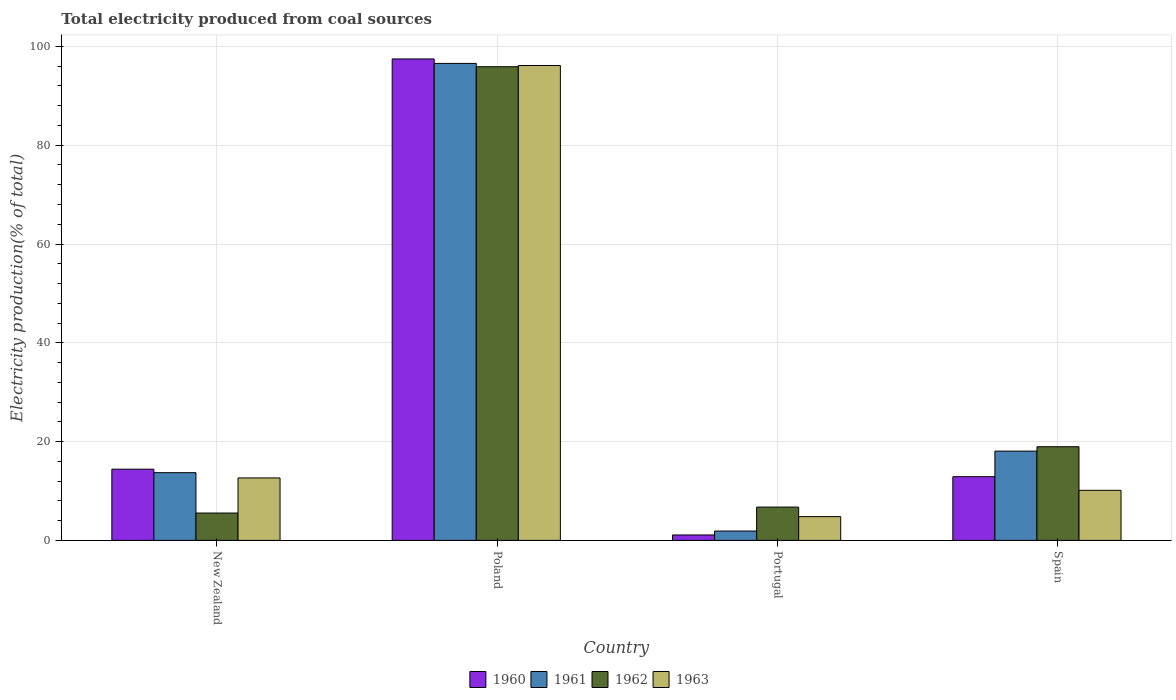How many groups of bars are there?
Ensure brevity in your answer.  4. Are the number of bars per tick equal to the number of legend labels?
Give a very brief answer. Yes. Are the number of bars on each tick of the X-axis equal?
Offer a very short reply. Yes. How many bars are there on the 2nd tick from the right?
Your answer should be compact. 4. What is the label of the 1st group of bars from the left?
Ensure brevity in your answer.  New Zealand. What is the total electricity produced in 1960 in Portugal?
Ensure brevity in your answer.  1.1. Across all countries, what is the maximum total electricity produced in 1960?
Provide a succinct answer. 97.46. Across all countries, what is the minimum total electricity produced in 1962?
Offer a very short reply. 5.54. In which country was the total electricity produced in 1962 maximum?
Offer a terse response. Poland. What is the total total electricity produced in 1962 in the graph?
Your response must be concise. 127.12. What is the difference between the total electricity produced in 1963 in Portugal and that in Spain?
Give a very brief answer. -5.33. What is the difference between the total electricity produced in 1962 in Spain and the total electricity produced in 1961 in New Zealand?
Offer a terse response. 5.25. What is the average total electricity produced in 1963 per country?
Ensure brevity in your answer.  30.93. What is the difference between the total electricity produced of/in 1961 and total electricity produced of/in 1963 in Poland?
Give a very brief answer. 0.43. In how many countries, is the total electricity produced in 1960 greater than 92 %?
Offer a terse response. 1. What is the ratio of the total electricity produced in 1960 in New Zealand to that in Poland?
Offer a terse response. 0.15. Is the total electricity produced in 1960 in New Zealand less than that in Poland?
Ensure brevity in your answer.  Yes. What is the difference between the highest and the second highest total electricity produced in 1961?
Your response must be concise. 78.49. What is the difference between the highest and the lowest total electricity produced in 1963?
Ensure brevity in your answer.  91.32. Is it the case that in every country, the sum of the total electricity produced in 1962 and total electricity produced in 1961 is greater than the sum of total electricity produced in 1963 and total electricity produced in 1960?
Make the answer very short. No. What does the 4th bar from the left in New Zealand represents?
Make the answer very short. 1963. How many countries are there in the graph?
Ensure brevity in your answer.  4. What is the difference between two consecutive major ticks on the Y-axis?
Your answer should be very brief. 20. Are the values on the major ticks of Y-axis written in scientific E-notation?
Provide a succinct answer. No. Does the graph contain grids?
Ensure brevity in your answer.  Yes. How are the legend labels stacked?
Your answer should be very brief. Horizontal. What is the title of the graph?
Your response must be concise. Total electricity produced from coal sources. Does "2009" appear as one of the legend labels in the graph?
Provide a succinct answer. No. What is the Electricity production(% of total) of 1960 in New Zealand?
Make the answer very short. 14.42. What is the Electricity production(% of total) in 1961 in New Zealand?
Ensure brevity in your answer.  13.71. What is the Electricity production(% of total) in 1962 in New Zealand?
Offer a terse response. 5.54. What is the Electricity production(% of total) of 1963 in New Zealand?
Your response must be concise. 12.64. What is the Electricity production(% of total) in 1960 in Poland?
Keep it short and to the point. 97.46. What is the Electricity production(% of total) of 1961 in Poland?
Provide a short and direct response. 96.56. What is the Electricity production(% of total) in 1962 in Poland?
Make the answer very short. 95.89. What is the Electricity production(% of total) in 1963 in Poland?
Your response must be concise. 96.13. What is the Electricity production(% of total) in 1960 in Portugal?
Your response must be concise. 1.1. What is the Electricity production(% of total) in 1961 in Portugal?
Ensure brevity in your answer.  1.89. What is the Electricity production(% of total) in 1962 in Portugal?
Provide a succinct answer. 6.74. What is the Electricity production(% of total) of 1963 in Portugal?
Make the answer very short. 4.81. What is the Electricity production(% of total) in 1960 in Spain?
Give a very brief answer. 12.9. What is the Electricity production(% of total) in 1961 in Spain?
Offer a very short reply. 18.07. What is the Electricity production(% of total) of 1962 in Spain?
Ensure brevity in your answer.  18.96. What is the Electricity production(% of total) in 1963 in Spain?
Offer a terse response. 10.14. Across all countries, what is the maximum Electricity production(% of total) of 1960?
Provide a succinct answer. 97.46. Across all countries, what is the maximum Electricity production(% of total) in 1961?
Provide a short and direct response. 96.56. Across all countries, what is the maximum Electricity production(% of total) of 1962?
Provide a short and direct response. 95.89. Across all countries, what is the maximum Electricity production(% of total) in 1963?
Offer a very short reply. 96.13. Across all countries, what is the minimum Electricity production(% of total) in 1960?
Offer a terse response. 1.1. Across all countries, what is the minimum Electricity production(% of total) of 1961?
Offer a terse response. 1.89. Across all countries, what is the minimum Electricity production(% of total) in 1962?
Your answer should be compact. 5.54. Across all countries, what is the minimum Electricity production(% of total) in 1963?
Give a very brief answer. 4.81. What is the total Electricity production(% of total) in 1960 in the graph?
Give a very brief answer. 125.88. What is the total Electricity production(% of total) in 1961 in the graph?
Your response must be concise. 130.23. What is the total Electricity production(% of total) in 1962 in the graph?
Give a very brief answer. 127.12. What is the total Electricity production(% of total) of 1963 in the graph?
Keep it short and to the point. 123.72. What is the difference between the Electricity production(% of total) in 1960 in New Zealand and that in Poland?
Offer a very short reply. -83.05. What is the difference between the Electricity production(% of total) in 1961 in New Zealand and that in Poland?
Your response must be concise. -82.85. What is the difference between the Electricity production(% of total) of 1962 in New Zealand and that in Poland?
Give a very brief answer. -90.35. What is the difference between the Electricity production(% of total) in 1963 in New Zealand and that in Poland?
Ensure brevity in your answer.  -83.49. What is the difference between the Electricity production(% of total) in 1960 in New Zealand and that in Portugal?
Ensure brevity in your answer.  13.32. What is the difference between the Electricity production(% of total) in 1961 in New Zealand and that in Portugal?
Your answer should be very brief. 11.81. What is the difference between the Electricity production(% of total) in 1962 in New Zealand and that in Portugal?
Your answer should be compact. -1.2. What is the difference between the Electricity production(% of total) of 1963 in New Zealand and that in Portugal?
Provide a succinct answer. 7.83. What is the difference between the Electricity production(% of total) of 1960 in New Zealand and that in Spain?
Provide a short and direct response. 1.52. What is the difference between the Electricity production(% of total) of 1961 in New Zealand and that in Spain?
Offer a very short reply. -4.36. What is the difference between the Electricity production(% of total) in 1962 in New Zealand and that in Spain?
Your answer should be very brief. -13.42. What is the difference between the Electricity production(% of total) of 1963 in New Zealand and that in Spain?
Give a very brief answer. 2.5. What is the difference between the Electricity production(% of total) in 1960 in Poland and that in Portugal?
Give a very brief answer. 96.36. What is the difference between the Electricity production(% of total) of 1961 in Poland and that in Portugal?
Provide a succinct answer. 94.66. What is the difference between the Electricity production(% of total) of 1962 in Poland and that in Portugal?
Offer a terse response. 89.15. What is the difference between the Electricity production(% of total) of 1963 in Poland and that in Portugal?
Your response must be concise. 91.32. What is the difference between the Electricity production(% of total) of 1960 in Poland and that in Spain?
Your answer should be compact. 84.56. What is the difference between the Electricity production(% of total) of 1961 in Poland and that in Spain?
Provide a succinct answer. 78.49. What is the difference between the Electricity production(% of total) in 1962 in Poland and that in Spain?
Ensure brevity in your answer.  76.93. What is the difference between the Electricity production(% of total) of 1963 in Poland and that in Spain?
Make the answer very short. 86. What is the difference between the Electricity production(% of total) of 1960 in Portugal and that in Spain?
Provide a succinct answer. -11.8. What is the difference between the Electricity production(% of total) of 1961 in Portugal and that in Spain?
Offer a terse response. -16.18. What is the difference between the Electricity production(% of total) in 1962 in Portugal and that in Spain?
Offer a terse response. -12.22. What is the difference between the Electricity production(% of total) of 1963 in Portugal and that in Spain?
Make the answer very short. -5.33. What is the difference between the Electricity production(% of total) of 1960 in New Zealand and the Electricity production(% of total) of 1961 in Poland?
Your answer should be very brief. -82.14. What is the difference between the Electricity production(% of total) of 1960 in New Zealand and the Electricity production(% of total) of 1962 in Poland?
Your answer should be compact. -81.47. What is the difference between the Electricity production(% of total) in 1960 in New Zealand and the Electricity production(% of total) in 1963 in Poland?
Your answer should be very brief. -81.71. What is the difference between the Electricity production(% of total) in 1961 in New Zealand and the Electricity production(% of total) in 1962 in Poland?
Your answer should be very brief. -82.18. What is the difference between the Electricity production(% of total) of 1961 in New Zealand and the Electricity production(% of total) of 1963 in Poland?
Ensure brevity in your answer.  -82.42. What is the difference between the Electricity production(% of total) in 1962 in New Zealand and the Electricity production(% of total) in 1963 in Poland?
Keep it short and to the point. -90.6. What is the difference between the Electricity production(% of total) of 1960 in New Zealand and the Electricity production(% of total) of 1961 in Portugal?
Ensure brevity in your answer.  12.52. What is the difference between the Electricity production(% of total) in 1960 in New Zealand and the Electricity production(% of total) in 1962 in Portugal?
Offer a very short reply. 7.68. What is the difference between the Electricity production(% of total) in 1960 in New Zealand and the Electricity production(% of total) in 1963 in Portugal?
Your answer should be compact. 9.61. What is the difference between the Electricity production(% of total) in 1961 in New Zealand and the Electricity production(% of total) in 1962 in Portugal?
Give a very brief answer. 6.97. What is the difference between the Electricity production(% of total) in 1961 in New Zealand and the Electricity production(% of total) in 1963 in Portugal?
Provide a short and direct response. 8.9. What is the difference between the Electricity production(% of total) in 1962 in New Zealand and the Electricity production(% of total) in 1963 in Portugal?
Keep it short and to the point. 0.73. What is the difference between the Electricity production(% of total) of 1960 in New Zealand and the Electricity production(% of total) of 1961 in Spain?
Your answer should be compact. -3.65. What is the difference between the Electricity production(% of total) of 1960 in New Zealand and the Electricity production(% of total) of 1962 in Spain?
Offer a terse response. -4.54. What is the difference between the Electricity production(% of total) in 1960 in New Zealand and the Electricity production(% of total) in 1963 in Spain?
Provide a short and direct response. 4.28. What is the difference between the Electricity production(% of total) of 1961 in New Zealand and the Electricity production(% of total) of 1962 in Spain?
Provide a short and direct response. -5.25. What is the difference between the Electricity production(% of total) in 1961 in New Zealand and the Electricity production(% of total) in 1963 in Spain?
Provide a succinct answer. 3.57. What is the difference between the Electricity production(% of total) in 1962 in New Zealand and the Electricity production(% of total) in 1963 in Spain?
Offer a very short reply. -4.6. What is the difference between the Electricity production(% of total) of 1960 in Poland and the Electricity production(% of total) of 1961 in Portugal?
Make the answer very short. 95.57. What is the difference between the Electricity production(% of total) of 1960 in Poland and the Electricity production(% of total) of 1962 in Portugal?
Provide a succinct answer. 90.72. What is the difference between the Electricity production(% of total) of 1960 in Poland and the Electricity production(% of total) of 1963 in Portugal?
Ensure brevity in your answer.  92.65. What is the difference between the Electricity production(% of total) in 1961 in Poland and the Electricity production(% of total) in 1962 in Portugal?
Your answer should be compact. 89.82. What is the difference between the Electricity production(% of total) of 1961 in Poland and the Electricity production(% of total) of 1963 in Portugal?
Your response must be concise. 91.75. What is the difference between the Electricity production(% of total) of 1962 in Poland and the Electricity production(% of total) of 1963 in Portugal?
Your answer should be very brief. 91.08. What is the difference between the Electricity production(% of total) of 1960 in Poland and the Electricity production(% of total) of 1961 in Spain?
Make the answer very short. 79.39. What is the difference between the Electricity production(% of total) of 1960 in Poland and the Electricity production(% of total) of 1962 in Spain?
Give a very brief answer. 78.51. What is the difference between the Electricity production(% of total) in 1960 in Poland and the Electricity production(% of total) in 1963 in Spain?
Offer a very short reply. 87.33. What is the difference between the Electricity production(% of total) of 1961 in Poland and the Electricity production(% of total) of 1962 in Spain?
Offer a terse response. 77.6. What is the difference between the Electricity production(% of total) of 1961 in Poland and the Electricity production(% of total) of 1963 in Spain?
Your answer should be compact. 86.42. What is the difference between the Electricity production(% of total) of 1962 in Poland and the Electricity production(% of total) of 1963 in Spain?
Your answer should be very brief. 85.75. What is the difference between the Electricity production(% of total) of 1960 in Portugal and the Electricity production(% of total) of 1961 in Spain?
Ensure brevity in your answer.  -16.97. What is the difference between the Electricity production(% of total) in 1960 in Portugal and the Electricity production(% of total) in 1962 in Spain?
Your answer should be compact. -17.86. What is the difference between the Electricity production(% of total) in 1960 in Portugal and the Electricity production(% of total) in 1963 in Spain?
Offer a very short reply. -9.04. What is the difference between the Electricity production(% of total) in 1961 in Portugal and the Electricity production(% of total) in 1962 in Spain?
Offer a terse response. -17.06. What is the difference between the Electricity production(% of total) in 1961 in Portugal and the Electricity production(% of total) in 1963 in Spain?
Offer a terse response. -8.24. What is the difference between the Electricity production(% of total) of 1962 in Portugal and the Electricity production(% of total) of 1963 in Spain?
Give a very brief answer. -3.4. What is the average Electricity production(% of total) of 1960 per country?
Offer a terse response. 31.47. What is the average Electricity production(% of total) of 1961 per country?
Give a very brief answer. 32.56. What is the average Electricity production(% of total) in 1962 per country?
Offer a very short reply. 31.78. What is the average Electricity production(% of total) in 1963 per country?
Offer a terse response. 30.93. What is the difference between the Electricity production(% of total) of 1960 and Electricity production(% of total) of 1961 in New Zealand?
Your answer should be compact. 0.71. What is the difference between the Electricity production(% of total) of 1960 and Electricity production(% of total) of 1962 in New Zealand?
Offer a terse response. 8.88. What is the difference between the Electricity production(% of total) of 1960 and Electricity production(% of total) of 1963 in New Zealand?
Ensure brevity in your answer.  1.78. What is the difference between the Electricity production(% of total) in 1961 and Electricity production(% of total) in 1962 in New Zealand?
Offer a very short reply. 8.17. What is the difference between the Electricity production(% of total) of 1961 and Electricity production(% of total) of 1963 in New Zealand?
Offer a terse response. 1.07. What is the difference between the Electricity production(% of total) in 1962 and Electricity production(% of total) in 1963 in New Zealand?
Give a very brief answer. -7.1. What is the difference between the Electricity production(% of total) of 1960 and Electricity production(% of total) of 1961 in Poland?
Provide a succinct answer. 0.91. What is the difference between the Electricity production(% of total) in 1960 and Electricity production(% of total) in 1962 in Poland?
Your answer should be compact. 1.57. What is the difference between the Electricity production(% of total) in 1960 and Electricity production(% of total) in 1963 in Poland?
Your response must be concise. 1.33. What is the difference between the Electricity production(% of total) of 1961 and Electricity production(% of total) of 1962 in Poland?
Provide a short and direct response. 0.67. What is the difference between the Electricity production(% of total) in 1961 and Electricity production(% of total) in 1963 in Poland?
Ensure brevity in your answer.  0.43. What is the difference between the Electricity production(% of total) in 1962 and Electricity production(% of total) in 1963 in Poland?
Provide a short and direct response. -0.24. What is the difference between the Electricity production(% of total) in 1960 and Electricity production(% of total) in 1961 in Portugal?
Make the answer very short. -0.8. What is the difference between the Electricity production(% of total) in 1960 and Electricity production(% of total) in 1962 in Portugal?
Your response must be concise. -5.64. What is the difference between the Electricity production(% of total) of 1960 and Electricity production(% of total) of 1963 in Portugal?
Make the answer very short. -3.71. What is the difference between the Electricity production(% of total) of 1961 and Electricity production(% of total) of 1962 in Portugal?
Make the answer very short. -4.85. What is the difference between the Electricity production(% of total) in 1961 and Electricity production(% of total) in 1963 in Portugal?
Make the answer very short. -2.91. What is the difference between the Electricity production(% of total) in 1962 and Electricity production(% of total) in 1963 in Portugal?
Offer a terse response. 1.93. What is the difference between the Electricity production(% of total) of 1960 and Electricity production(% of total) of 1961 in Spain?
Keep it short and to the point. -5.17. What is the difference between the Electricity production(% of total) of 1960 and Electricity production(% of total) of 1962 in Spain?
Your answer should be very brief. -6.06. What is the difference between the Electricity production(% of total) in 1960 and Electricity production(% of total) in 1963 in Spain?
Your response must be concise. 2.76. What is the difference between the Electricity production(% of total) of 1961 and Electricity production(% of total) of 1962 in Spain?
Ensure brevity in your answer.  -0.88. What is the difference between the Electricity production(% of total) of 1961 and Electricity production(% of total) of 1963 in Spain?
Your answer should be compact. 7.94. What is the difference between the Electricity production(% of total) in 1962 and Electricity production(% of total) in 1963 in Spain?
Offer a terse response. 8.82. What is the ratio of the Electricity production(% of total) of 1960 in New Zealand to that in Poland?
Offer a terse response. 0.15. What is the ratio of the Electricity production(% of total) in 1961 in New Zealand to that in Poland?
Your response must be concise. 0.14. What is the ratio of the Electricity production(% of total) in 1962 in New Zealand to that in Poland?
Your answer should be compact. 0.06. What is the ratio of the Electricity production(% of total) in 1963 in New Zealand to that in Poland?
Provide a succinct answer. 0.13. What is the ratio of the Electricity production(% of total) of 1960 in New Zealand to that in Portugal?
Ensure brevity in your answer.  13.13. What is the ratio of the Electricity production(% of total) of 1961 in New Zealand to that in Portugal?
Provide a short and direct response. 7.24. What is the ratio of the Electricity production(% of total) in 1962 in New Zealand to that in Portugal?
Give a very brief answer. 0.82. What is the ratio of the Electricity production(% of total) of 1963 in New Zealand to that in Portugal?
Offer a very short reply. 2.63. What is the ratio of the Electricity production(% of total) in 1960 in New Zealand to that in Spain?
Offer a terse response. 1.12. What is the ratio of the Electricity production(% of total) of 1961 in New Zealand to that in Spain?
Give a very brief answer. 0.76. What is the ratio of the Electricity production(% of total) in 1962 in New Zealand to that in Spain?
Offer a very short reply. 0.29. What is the ratio of the Electricity production(% of total) in 1963 in New Zealand to that in Spain?
Offer a very short reply. 1.25. What is the ratio of the Electricity production(% of total) in 1960 in Poland to that in Portugal?
Your answer should be very brief. 88.77. What is the ratio of the Electricity production(% of total) of 1961 in Poland to that in Portugal?
Keep it short and to the point. 50.97. What is the ratio of the Electricity production(% of total) in 1962 in Poland to that in Portugal?
Offer a very short reply. 14.23. What is the ratio of the Electricity production(% of total) in 1963 in Poland to that in Portugal?
Give a very brief answer. 19.99. What is the ratio of the Electricity production(% of total) in 1960 in Poland to that in Spain?
Offer a very short reply. 7.56. What is the ratio of the Electricity production(% of total) of 1961 in Poland to that in Spain?
Offer a terse response. 5.34. What is the ratio of the Electricity production(% of total) of 1962 in Poland to that in Spain?
Your answer should be compact. 5.06. What is the ratio of the Electricity production(% of total) of 1963 in Poland to that in Spain?
Make the answer very short. 9.48. What is the ratio of the Electricity production(% of total) in 1960 in Portugal to that in Spain?
Offer a terse response. 0.09. What is the ratio of the Electricity production(% of total) in 1961 in Portugal to that in Spain?
Offer a very short reply. 0.1. What is the ratio of the Electricity production(% of total) of 1962 in Portugal to that in Spain?
Keep it short and to the point. 0.36. What is the ratio of the Electricity production(% of total) of 1963 in Portugal to that in Spain?
Provide a succinct answer. 0.47. What is the difference between the highest and the second highest Electricity production(% of total) in 1960?
Ensure brevity in your answer.  83.05. What is the difference between the highest and the second highest Electricity production(% of total) of 1961?
Ensure brevity in your answer.  78.49. What is the difference between the highest and the second highest Electricity production(% of total) of 1962?
Your answer should be very brief. 76.93. What is the difference between the highest and the second highest Electricity production(% of total) of 1963?
Make the answer very short. 83.49. What is the difference between the highest and the lowest Electricity production(% of total) of 1960?
Ensure brevity in your answer.  96.36. What is the difference between the highest and the lowest Electricity production(% of total) of 1961?
Give a very brief answer. 94.66. What is the difference between the highest and the lowest Electricity production(% of total) in 1962?
Ensure brevity in your answer.  90.35. What is the difference between the highest and the lowest Electricity production(% of total) of 1963?
Keep it short and to the point. 91.32. 